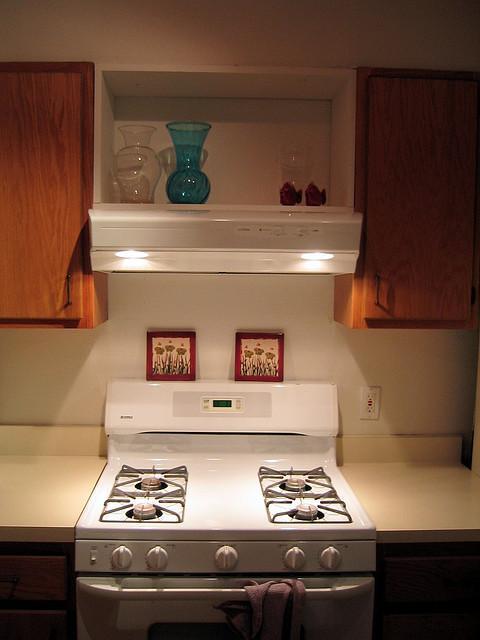How many vases are visible?
Give a very brief answer. 2. How many men are there?
Give a very brief answer. 0. 